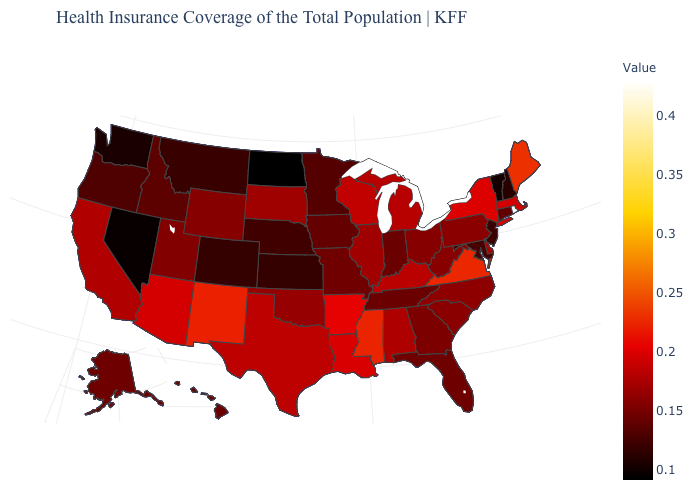Which states hav the highest value in the South?
Answer briefly. Virginia. Which states have the lowest value in the USA?
Short answer required. North Dakota. Which states have the highest value in the USA?
Give a very brief answer. Rhode Island. 